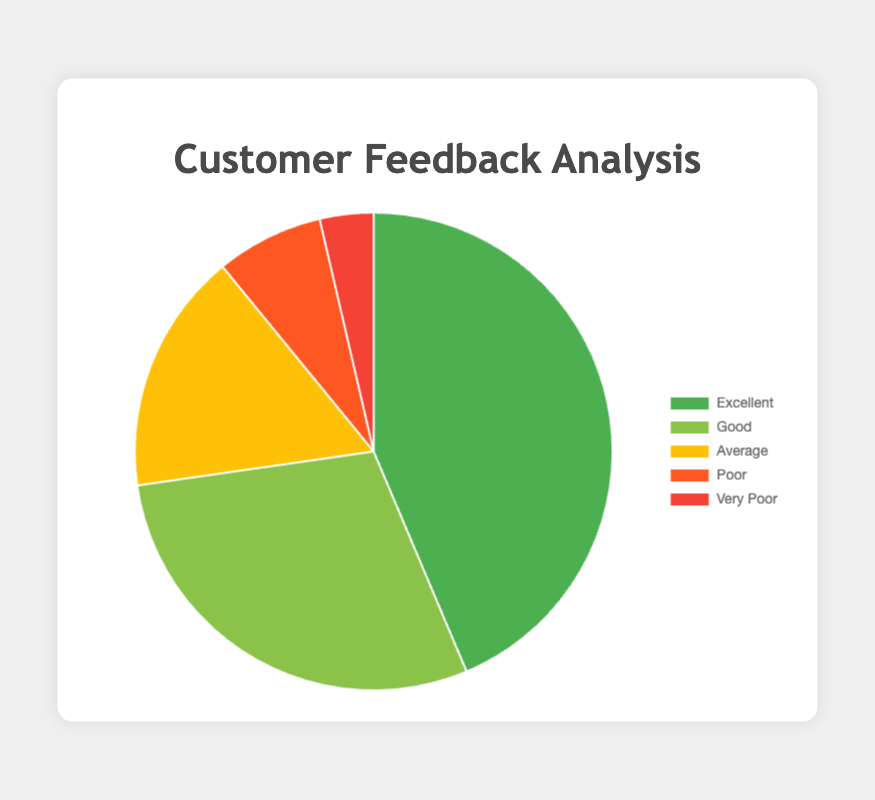What percentage of customers gave Excellent feedback? By examining the chart, we see that the number of Excellent feedbacks is 120. The total feedbacks are 275 (120+80+45+20+10). The percentage is calculated as (120/275)*100, which is approximately 43.6%.
Answer: 43.6% Which feedback category has the least number of responses? By observing the pie chart, we see that the Very Poor category, with 10 responses, has the least number of responses.
Answer: Very Poor What's the difference between the number of Good and Average feedbacks? Good feedback has 80 responses and Average feedback has 45 responses. The difference is 80 - 45 = 35.
Answer: 35 How many more Poor feedbacks are there compared to Very Poor feedbacks? Poor feedback has 20 responses, while Very Poor feedback has 10 responses. The difference is 20 - 10 = 10.
Answer: 10 Combined, what percentage of customers rated the service as either Poor or Very Poor? Poor feedbacks are 20 and Very Poor are 10, so combined they are 30. The total feedback is 275. The percentage is (30/275)*100, which is approximately 10.9%.
Answer: 10.9% Which category has the second highest number of responses? By comparing the segments, after Excellent (120), Good feedback has the second highest number of responses with 80.
Answer: Good What is the average number of feedbacks per category? The total number of feedbacks is 275 over 5 categories. The average is 275/5 = 55.
Answer: 55 How does the number of Poor feedbacks compare visually to Average feedbacks? The Poor feedback segment is smaller and appears less significant in the pie chart compared to the Average feedback segment.
Answer: Smaller How much more Excellent feedback is there than the combined total of Poor and Very Poor? Excellent feedback is 120. Combined Poor and Very Poor feedback is 20 + 10 = 30. The difference is 120 - 30 = 90.
Answer: 90 